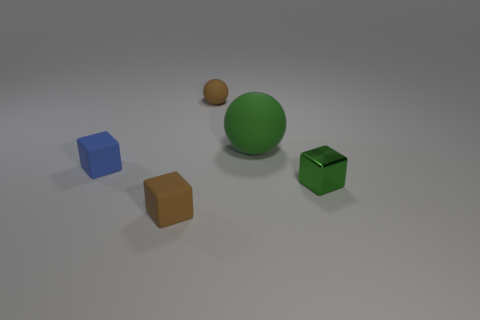Subtract all cyan cubes. Subtract all brown cylinders. How many cubes are left? 3 Subtract all red balls. How many gray blocks are left? 0 Add 1 small browns. How many small greens exist? 0 Subtract all tiny red metal things. Subtract all small metal blocks. How many objects are left? 4 Add 3 brown things. How many brown things are left? 5 Add 3 tiny brown balls. How many tiny brown balls exist? 4 Add 3 blue rubber blocks. How many objects exist? 8 Subtract all green spheres. How many spheres are left? 1 Subtract all green cubes. How many cubes are left? 2 Subtract 0 cyan cylinders. How many objects are left? 5 